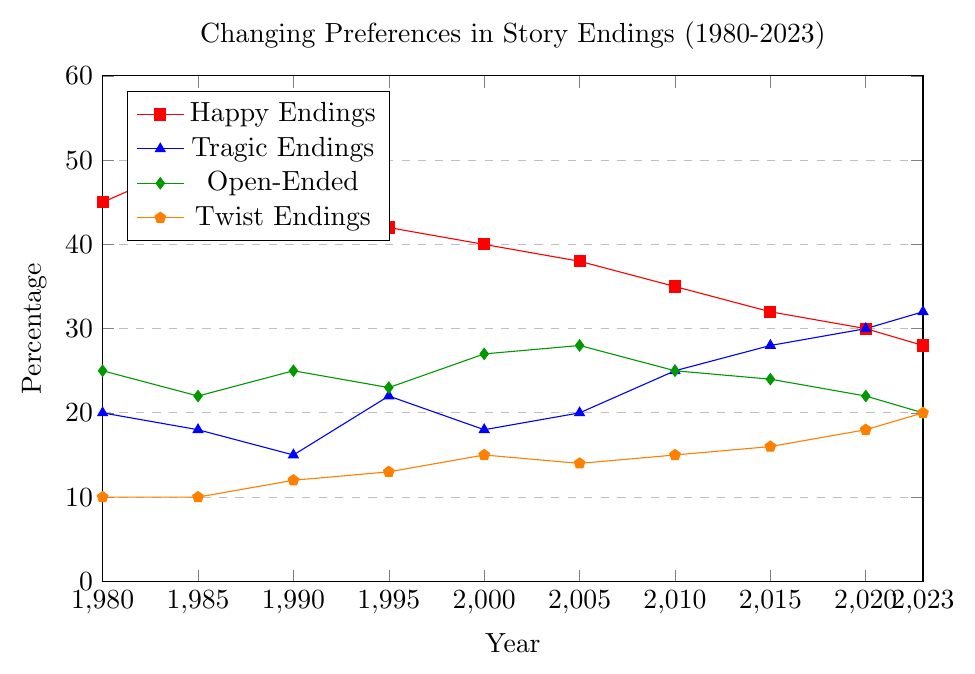Which type of ending has the highest percentage in 1980? In the 1980 data point, compare the percentages of Happy Endings, Tragic Endings, Open-Ended, and Twist Endings. The Happy Endings have a percentage of 45, which is the highest among the four types.
Answer: Happy Endings Between 2000 and 2023, which type of ending shows the most consistent trend (minimal fluctuations)? By visually inspecting the plot lines from 2000 to 2023, Open-Ended (green line) shows slight fluctuations compared to other types, thus indicating a relatively consistent trend.
Answer: Open-Ended How many percentage points did Tragic Endings increase from 1985 to 2023? Look at the Tragic Endings percentage in 1985 (18) and in 2023 (32). Calculate the difference: 32 - 18 = 14.
Answer: 14 In which year did Twist Endings surpass Happy Endings in percentage? Identify the years where the percentage for Twist Endings (orange) became higher than for Happy Endings (red). This occurs in 2023, where Twist Endings (20) surpass Happy Endings (28).
Answer: 2023 What’s the total percentage of Open-Ended and Twist Endings in 2010? Add the percentage of Open-Ended (25) and Twist Endings (15) for the year 2010: 25 + 15 = 40.
Answer: 40 Which type of ending has risen the most in preference from 2000 to 2023? Compare the percentage points increase from 2000 to 2023 for each ending type. Twist Endings increased from 15 to 20, which is the largest gain.
Answer: Twist Endings In what year do all endings except Happy have more than 20% preference? Find the year where Tragic Endings, Open-Ended, and Twist Endings each have more than 20%. In 2023, Tragic (32), Open-Ended (20), and Twist (20) all meet this condition.
Answer: 2023 During which period (1980 to 2000 or 2000 to 2023) did Happy Endings decline more steeply? Calculate the decrease in percentages: from 1980 (45) to 2000 (40) is a decline of 5; from 2000 (40) to 2023 (28) is a decline of 12. Happy Endings declined more steeply from 2000 to 2023.
Answer: 2000 to 2023 Which type of ending had the least variation in preference from 1980 to 2023? Comparing the ranges of percentages of each ending type from 1980 to 2023, Twist Endings (10 to 20) had the least variation (range of 10), as other types had larger ranges.
Answer: Twist Endings 